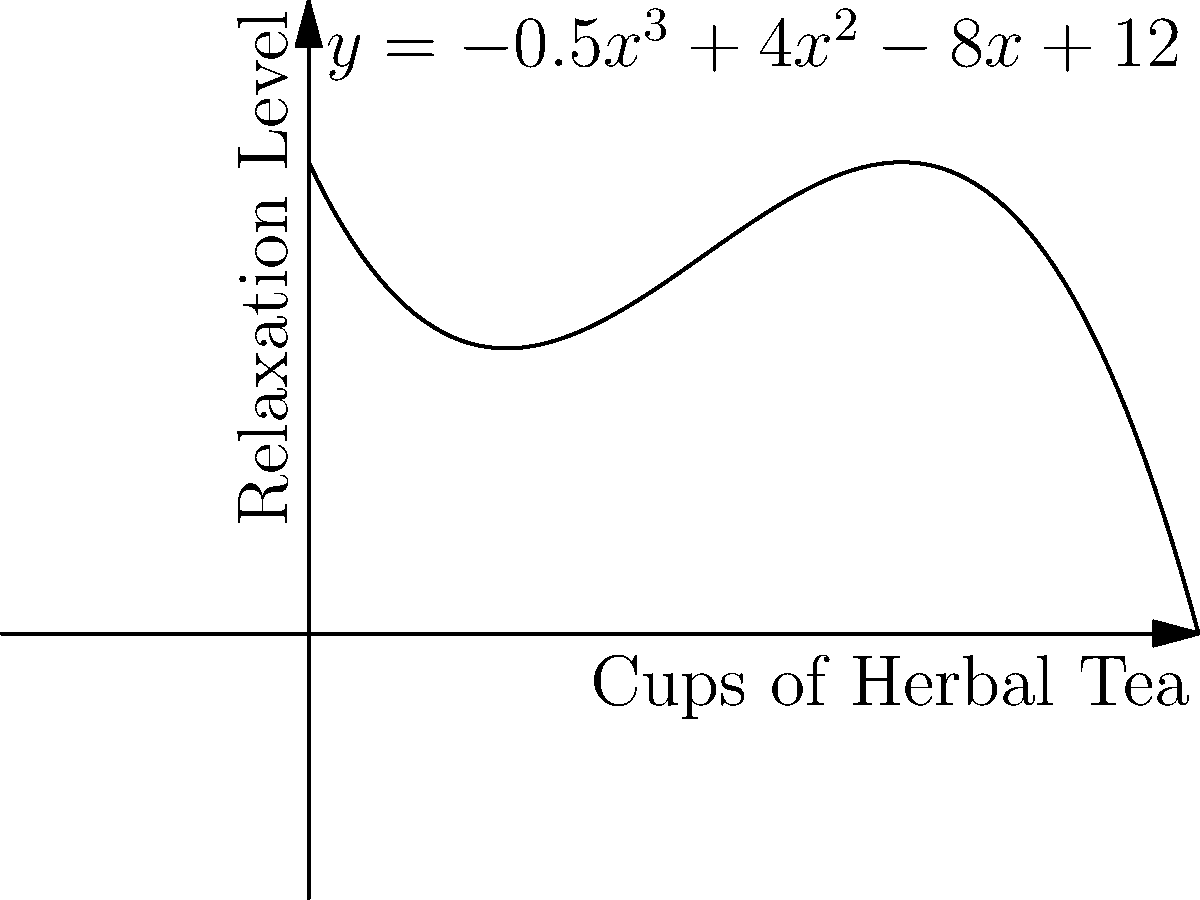As part of your wellness journey, you've been tracking the relationship between your daily herbal tea consumption and your relaxation levels. The polynomial function $y = -0.5x^3 + 4x^2 - 8x + 12$ represents this relationship, where $x$ is the number of cups of herbal tea consumed and $y$ is the relaxation level on a scale of 0 to 20. At how many cups of herbal tea does the relaxation level reach its maximum? To find the maximum relaxation level, we need to follow these steps:

1) The maximum point occurs where the derivative of the function equals zero. Let's find the derivative:
   $f'(x) = -1.5x^2 + 8x - 8$

2) Set the derivative to zero and solve for x:
   $-1.5x^2 + 8x - 8 = 0$

3) This is a quadratic equation. We can solve it using the quadratic formula:
   $x = \frac{-b \pm \sqrt{b^2 - 4ac}}{2a}$

   Where $a = -1.5$, $b = 8$, and $c = -8$

4) Plugging in these values:
   $x = \frac{-8 \pm \sqrt{64 - 4(-1.5)(-8)}}{2(-1.5)}$
   $= \frac{-8 \pm \sqrt{64 - 48}}{-3}$
   $= \frac{-8 \pm \sqrt{16}}{-3}$
   $= \frac{-8 \pm 4}{-3}$

5) This gives us two solutions:
   $x = \frac{-8 + 4}{-3} = \frac{-4}{-3} = \frac{4}{3}$ or $x = \frac{-8 - 4}{-3} = \frac{-12}{-3} = 4$

6) The second solution, $x = 4$, falls within our domain (0 to 6 cups of tea), so this is our answer.

Therefore, the relaxation level reaches its maximum when 4 cups of herbal tea are consumed.
Answer: 4 cups 